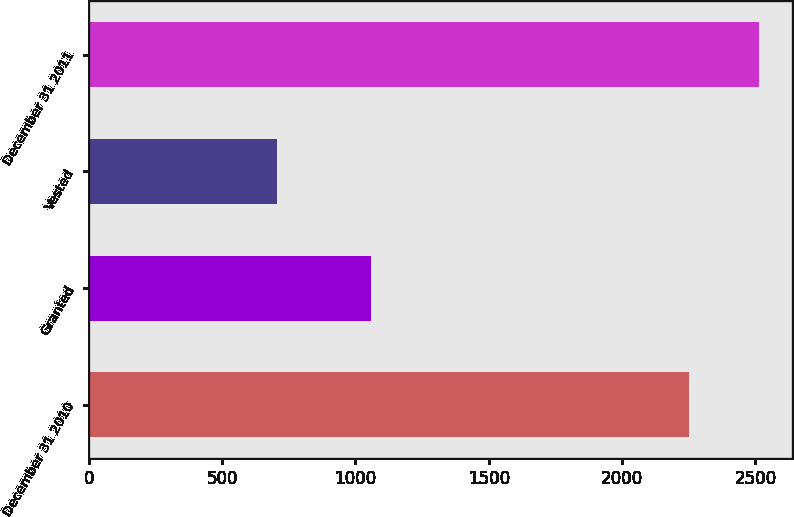Convert chart to OTSL. <chart><loc_0><loc_0><loc_500><loc_500><bar_chart><fcel>December 31 2010<fcel>Granted<fcel>Vested<fcel>December 31 2011<nl><fcel>2250<fcel>1059<fcel>706<fcel>2512<nl></chart> 